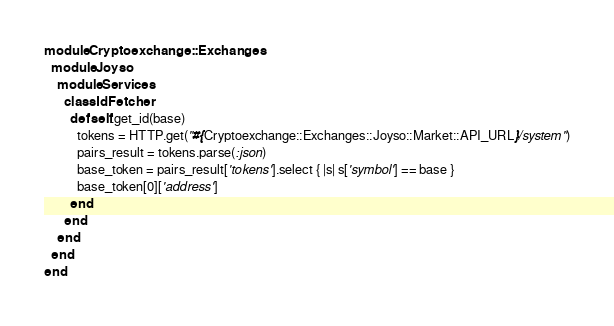<code> <loc_0><loc_0><loc_500><loc_500><_Ruby_>module Cryptoexchange::Exchanges
  module Joyso
    module Services
      class IdFetcher
        def self.get_id(base)
          tokens = HTTP.get("#{Cryptoexchange::Exchanges::Joyso::Market::API_URL}/system")
          pairs_result = tokens.parse(:json)
          base_token = pairs_result['tokens'].select { |s| s['symbol'] == base }
          base_token[0]['address']
        end
      end
    end
  end
end
</code> 